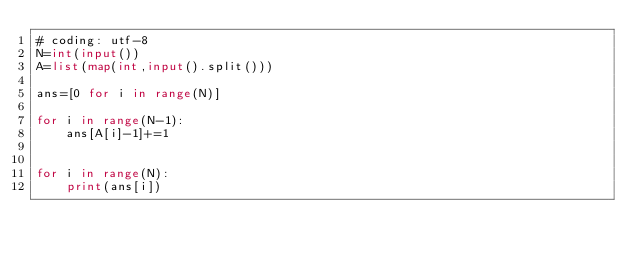Convert code to text. <code><loc_0><loc_0><loc_500><loc_500><_Python_># coding: utf-8
N=int(input())
A=list(map(int,input().split()))

ans=[0 for i in range(N)]

for i in range(N-1):
    ans[A[i]-1]+=1


for i in range(N):
    print(ans[i])</code> 